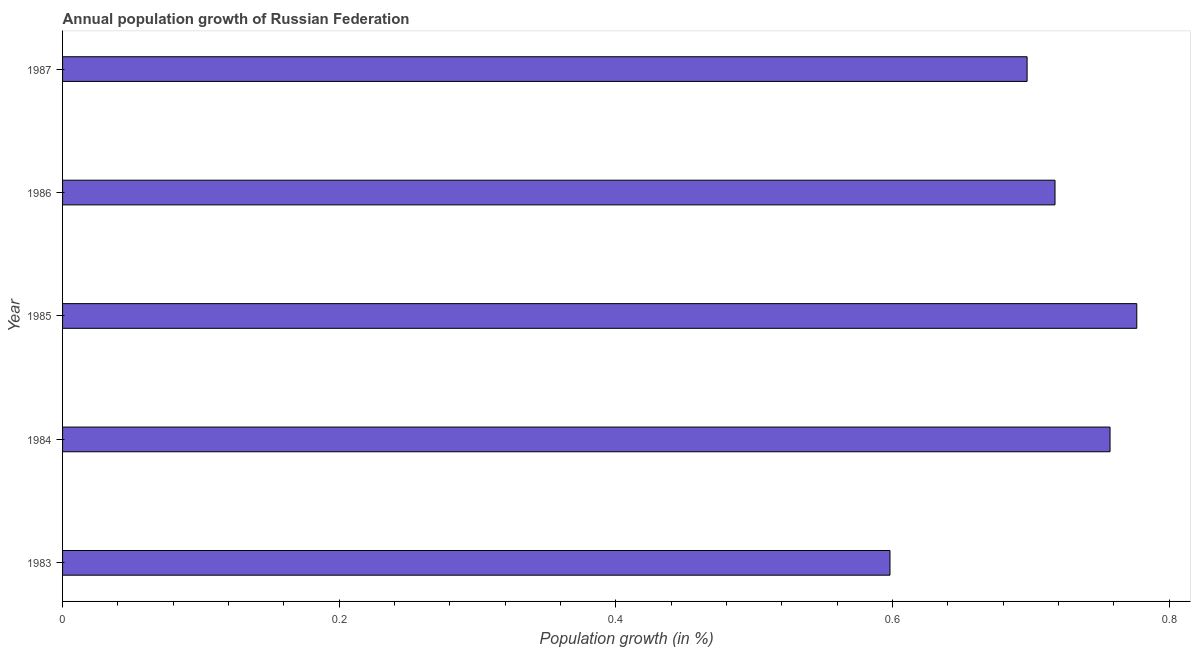What is the title of the graph?
Provide a short and direct response. Annual population growth of Russian Federation. What is the label or title of the X-axis?
Your answer should be very brief. Population growth (in %). What is the population growth in 1985?
Your answer should be very brief. 0.78. Across all years, what is the maximum population growth?
Give a very brief answer. 0.78. Across all years, what is the minimum population growth?
Your answer should be compact. 0.6. In which year was the population growth minimum?
Your answer should be very brief. 1983. What is the sum of the population growth?
Your answer should be very brief. 3.55. What is the difference between the population growth in 1985 and 1986?
Your answer should be very brief. 0.06. What is the average population growth per year?
Ensure brevity in your answer.  0.71. What is the median population growth?
Keep it short and to the point. 0.72. In how many years, is the population growth greater than 0.24 %?
Your response must be concise. 5. Do a majority of the years between 1987 and 1985 (inclusive) have population growth greater than 0.44 %?
Your answer should be compact. Yes. What is the ratio of the population growth in 1983 to that in 1987?
Your answer should be very brief. 0.86. Is the population growth in 1984 less than that in 1987?
Your response must be concise. No. Is the difference between the population growth in 1983 and 1986 greater than the difference between any two years?
Your answer should be very brief. No. What is the difference between the highest and the second highest population growth?
Keep it short and to the point. 0.02. Is the sum of the population growth in 1984 and 1985 greater than the maximum population growth across all years?
Your answer should be very brief. Yes. What is the difference between the highest and the lowest population growth?
Provide a short and direct response. 0.18. How many bars are there?
Provide a short and direct response. 5. Are all the bars in the graph horizontal?
Provide a succinct answer. Yes. Are the values on the major ticks of X-axis written in scientific E-notation?
Provide a short and direct response. No. What is the Population growth (in %) in 1983?
Make the answer very short. 0.6. What is the Population growth (in %) in 1984?
Offer a terse response. 0.76. What is the Population growth (in %) of 1985?
Ensure brevity in your answer.  0.78. What is the Population growth (in %) in 1986?
Keep it short and to the point. 0.72. What is the Population growth (in %) of 1987?
Offer a terse response. 0.7. What is the difference between the Population growth (in %) in 1983 and 1984?
Your response must be concise. -0.16. What is the difference between the Population growth (in %) in 1983 and 1985?
Ensure brevity in your answer.  -0.18. What is the difference between the Population growth (in %) in 1983 and 1986?
Offer a very short reply. -0.12. What is the difference between the Population growth (in %) in 1983 and 1987?
Keep it short and to the point. -0.1. What is the difference between the Population growth (in %) in 1984 and 1985?
Offer a very short reply. -0.02. What is the difference between the Population growth (in %) in 1984 and 1986?
Your response must be concise. 0.04. What is the difference between the Population growth (in %) in 1984 and 1987?
Provide a succinct answer. 0.06. What is the difference between the Population growth (in %) in 1985 and 1986?
Offer a terse response. 0.06. What is the difference between the Population growth (in %) in 1985 and 1987?
Give a very brief answer. 0.08. What is the difference between the Population growth (in %) in 1986 and 1987?
Make the answer very short. 0.02. What is the ratio of the Population growth (in %) in 1983 to that in 1984?
Your answer should be very brief. 0.79. What is the ratio of the Population growth (in %) in 1983 to that in 1985?
Your answer should be very brief. 0.77. What is the ratio of the Population growth (in %) in 1983 to that in 1986?
Keep it short and to the point. 0.83. What is the ratio of the Population growth (in %) in 1983 to that in 1987?
Make the answer very short. 0.86. What is the ratio of the Population growth (in %) in 1984 to that in 1986?
Provide a short and direct response. 1.05. What is the ratio of the Population growth (in %) in 1984 to that in 1987?
Offer a terse response. 1.09. What is the ratio of the Population growth (in %) in 1985 to that in 1986?
Your answer should be compact. 1.08. What is the ratio of the Population growth (in %) in 1985 to that in 1987?
Offer a terse response. 1.11. What is the ratio of the Population growth (in %) in 1986 to that in 1987?
Offer a terse response. 1.03. 